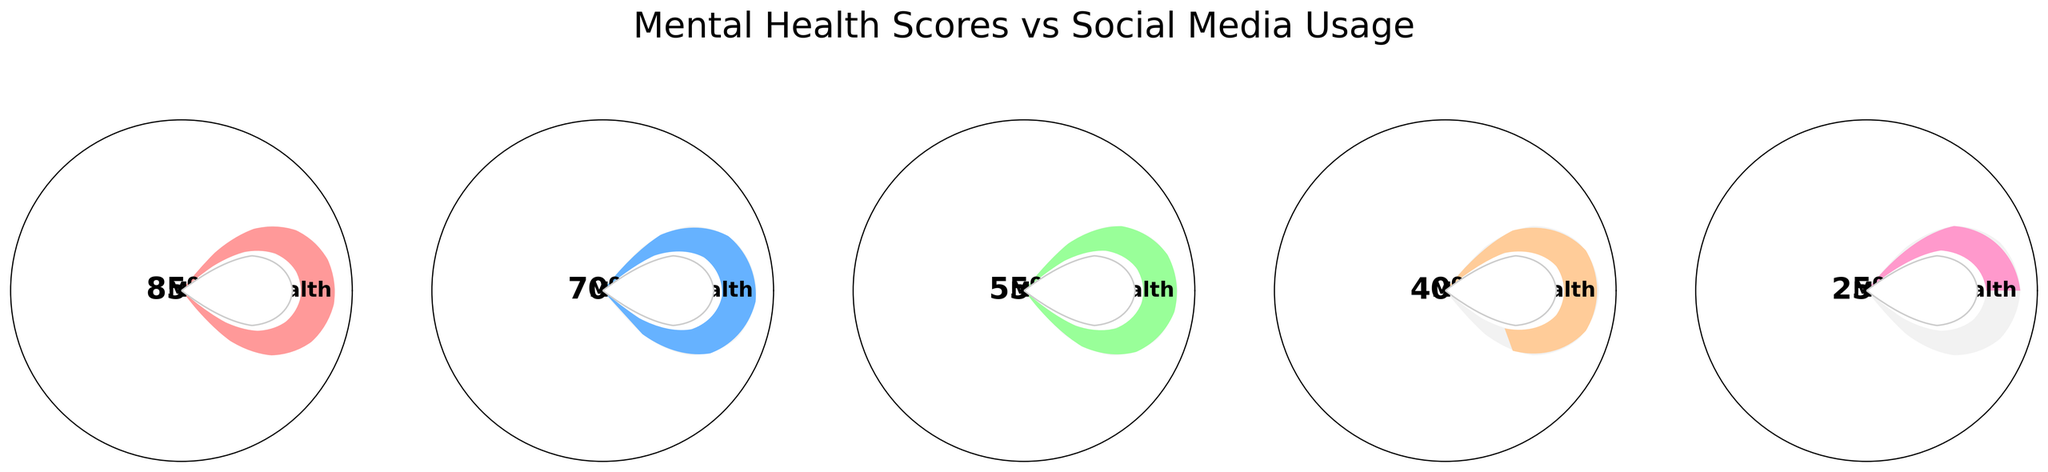What's the highest mental health score displayed in the figure? The highest score is visible on the first gauge, which shows a score of 85%.
Answer: 85% How many hours of social media usage correspond to the lowest mental health score? The lowest score is visible on the fifth gauge, which also shows 9 hours per day usage.
Answer: 9 hours/day What is the average mental health score across all gauges? Add all the mental health scores (85 + 70 + 55 + 40 + 25) = 275 and divide by the number of gauges (5). The average score is 275/5 = 55%.
Answer: 55% Which social media usage category is associated with a mental health score of 70%? The second gauge shows a mental health score of 70%, paired with a social media usage of 3 hours per day.
Answer: 3 hours/day Is there a general trend in mental health scores as social media usage increases? By inspecting the gauges from left to right, we observe that mental health scores decrease as social media usage increases from 1 to 9 hours per day.
Answer: Decreases What is the total combined social media usage shown across all gauges? Add the social media usage hours (1 + 3 + 5 + 7 + 9) = 25 hours/day.
Answer: 25 hours/day Which usage category has a score closest to the average mental health score? The average mental health score is 55%. The third gauge, showing a score of 55% with 5 hours per day usage, matches the average.
Answer: 5 hours/day Are there any usage categories where the mental health score is over 70%? The first two gauges show mental health scores over 70%, with respective usages of 1 and 3 hours/day.
Answer: 1 and 3 hours/day What percentage drop in mental health score is observed from 1 hour of social media use to 9 hours? Subtract the mental health score at 9 hours (25%) from the score at 1 hour (85%), which equals a drop of 60%.
Answer: 60% Which gauge displays a mental health score with an even number percentage? The second gauge displays a mental health score of 70%, which is an even number.
Answer: 70% 